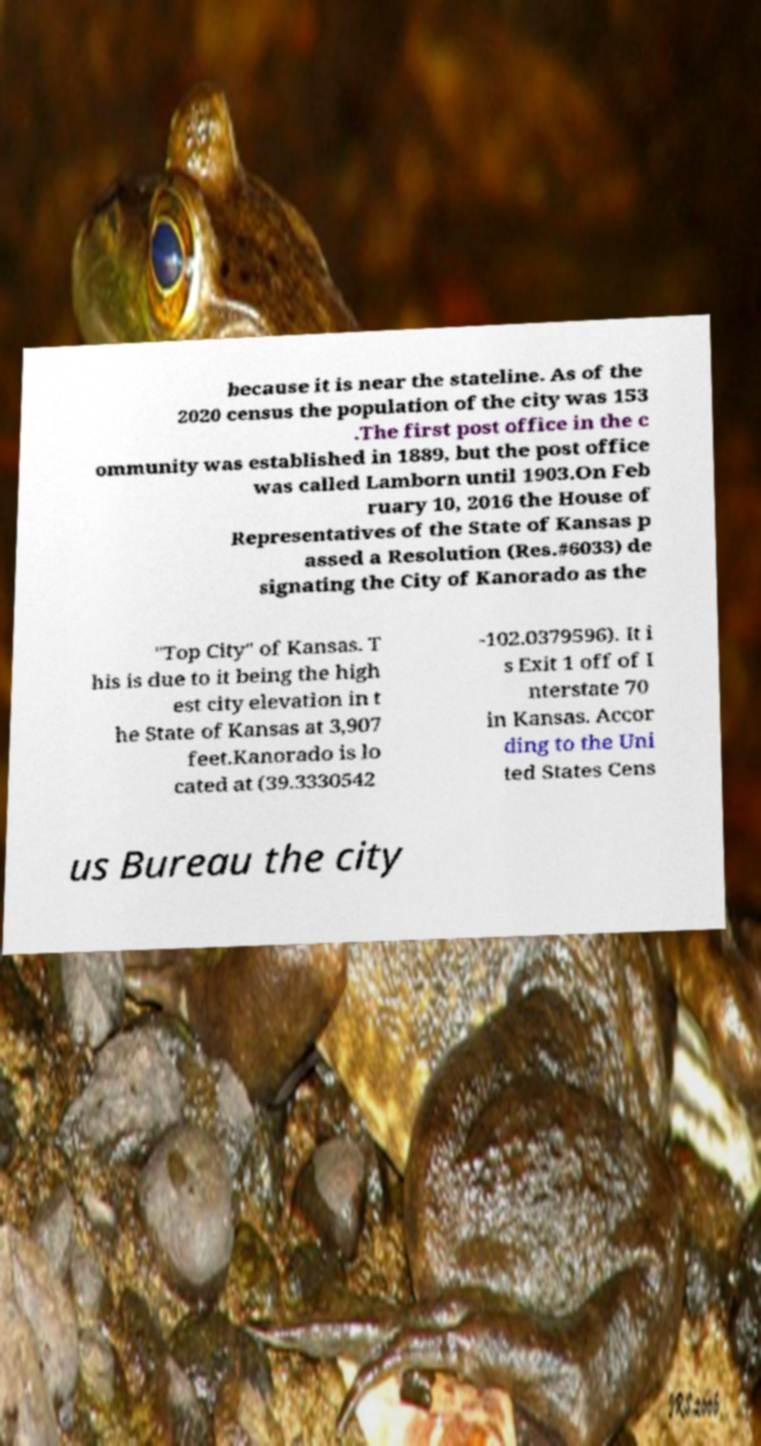Can you read and provide the text displayed in the image?This photo seems to have some interesting text. Can you extract and type it out for me? because it is near the stateline. As of the 2020 census the population of the city was 153 .The first post office in the c ommunity was established in 1889, but the post office was called Lamborn until 1903.On Feb ruary 10, 2016 the House of Representatives of the State of Kansas p assed a Resolution (Res.#6033) de signating the City of Kanorado as the "Top City" of Kansas. T his is due to it being the high est city elevation in t he State of Kansas at 3,907 feet.Kanorado is lo cated at (39.3330542 -102.0379596). It i s Exit 1 off of I nterstate 70 in Kansas. Accor ding to the Uni ted States Cens us Bureau the city 